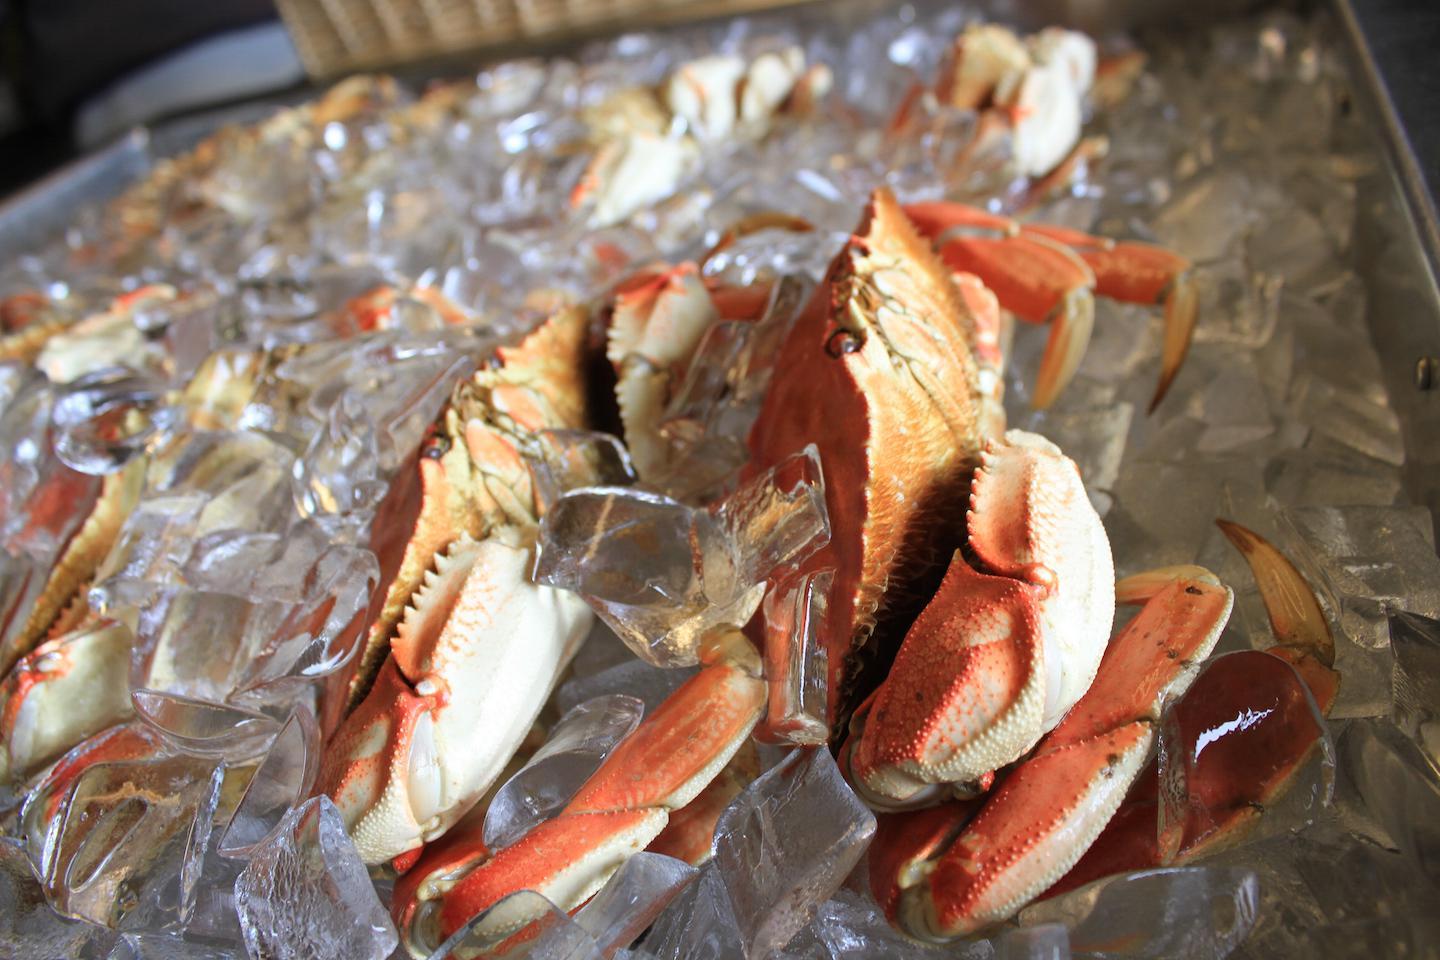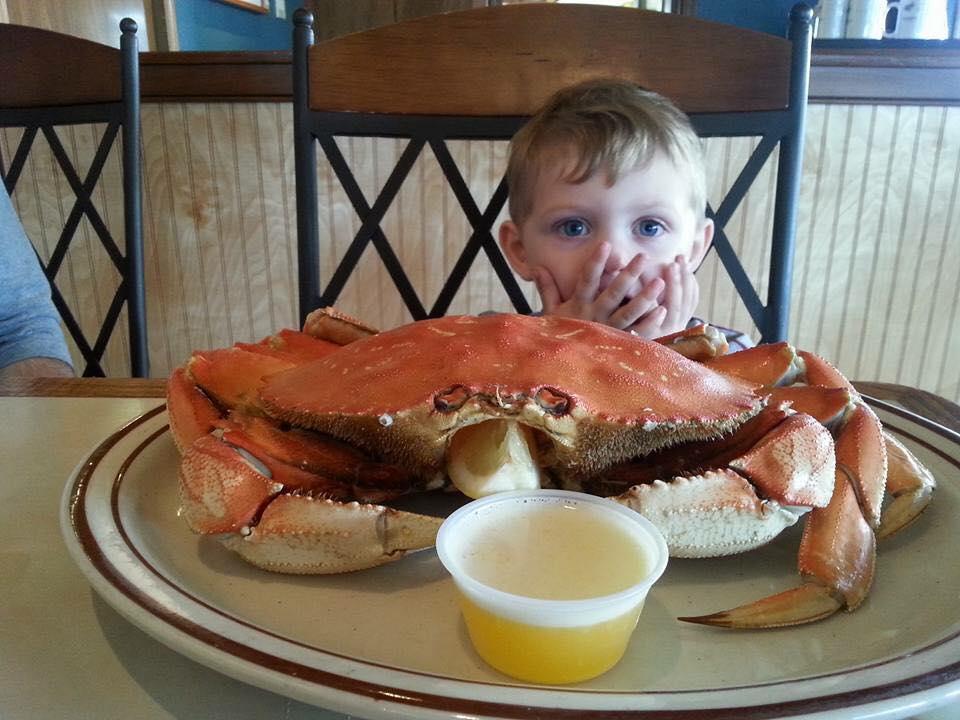The first image is the image on the left, the second image is the image on the right. For the images displayed, is the sentence "A person is holding a crab in the image on the left." factually correct? Answer yes or no. No. The first image is the image on the left, the second image is the image on the right. For the images shown, is this caption "Each image includes a hand near one crab, and one image shows a bare hand grasping a crab and holding it up in front of a body of water." true? Answer yes or no. No. 